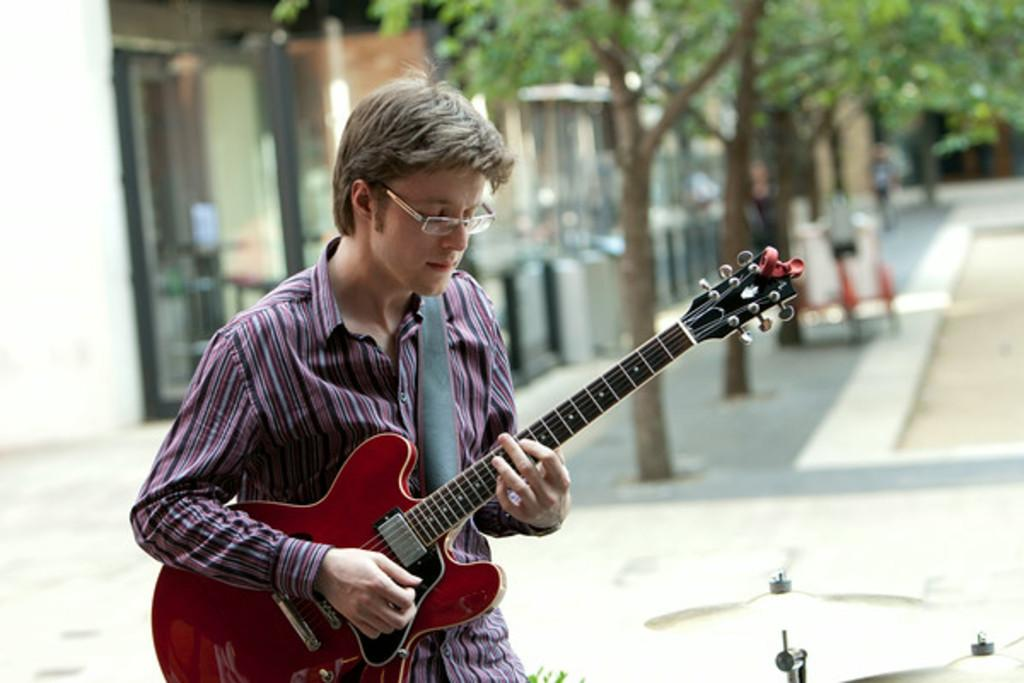Who is the person in the image? There is a man in the image. What can be seen on the man's face? The man is wearing spectacles. What is the color of the man's hair? The man has grey hair. What is the man holding in the image? The man is holding a guitar. What is the man doing with the guitar? The man is playing the guitar. What type of vegetation is visible on the footpath? There are trees on the footpath. What type of sofa can be seen in the image? There is no sofa present in the image. Can you tell me how many stitches are on the man's shirt in the image? The image does not provide enough detail to count the stitches on the man's shirt. 